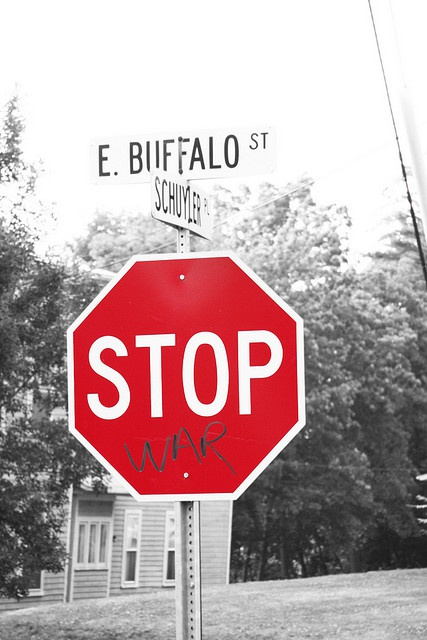Describe the objects in this image and their specific colors. I can see a stop sign in white, brown, whitesmoke, and gray tones in this image. 